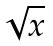Convert formula to latex. <formula><loc_0><loc_0><loc_500><loc_500>\sqrt { x }</formula> 